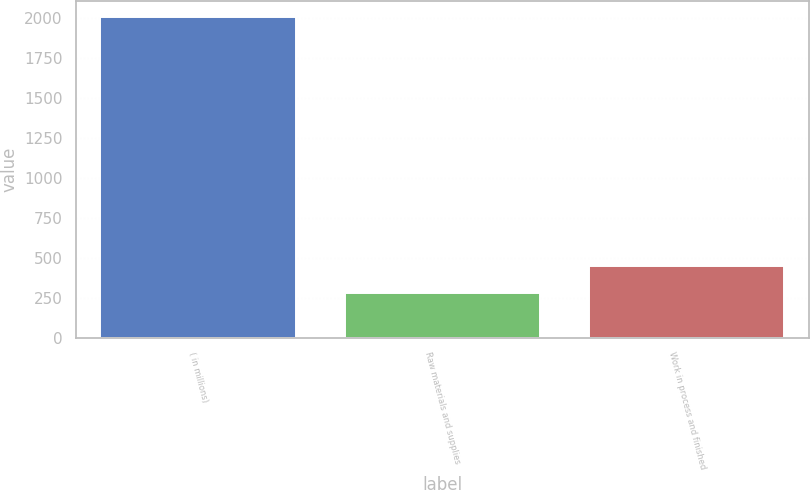Convert chart to OTSL. <chart><loc_0><loc_0><loc_500><loc_500><bar_chart><fcel>( in millions)<fcel>Raw materials and supplies<fcel>Work in process and finished<nl><fcel>2005<fcel>277.4<fcel>450.16<nl></chart> 